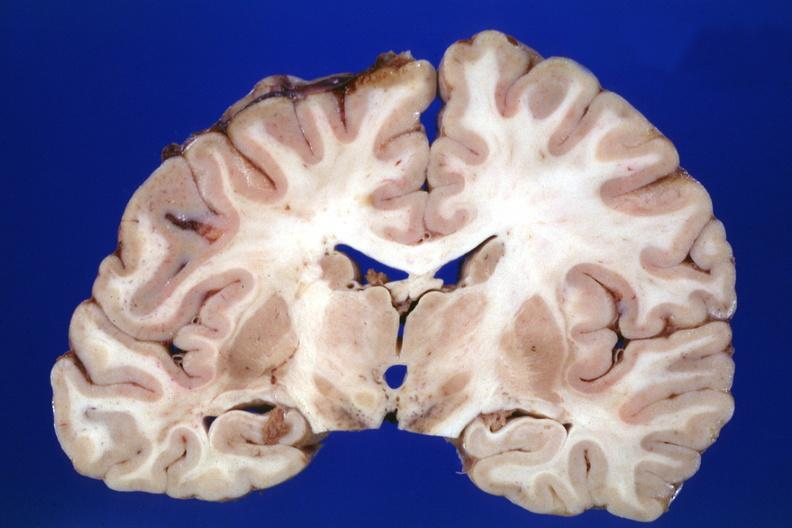s this section present?
Answer the question using a single word or phrase. No 